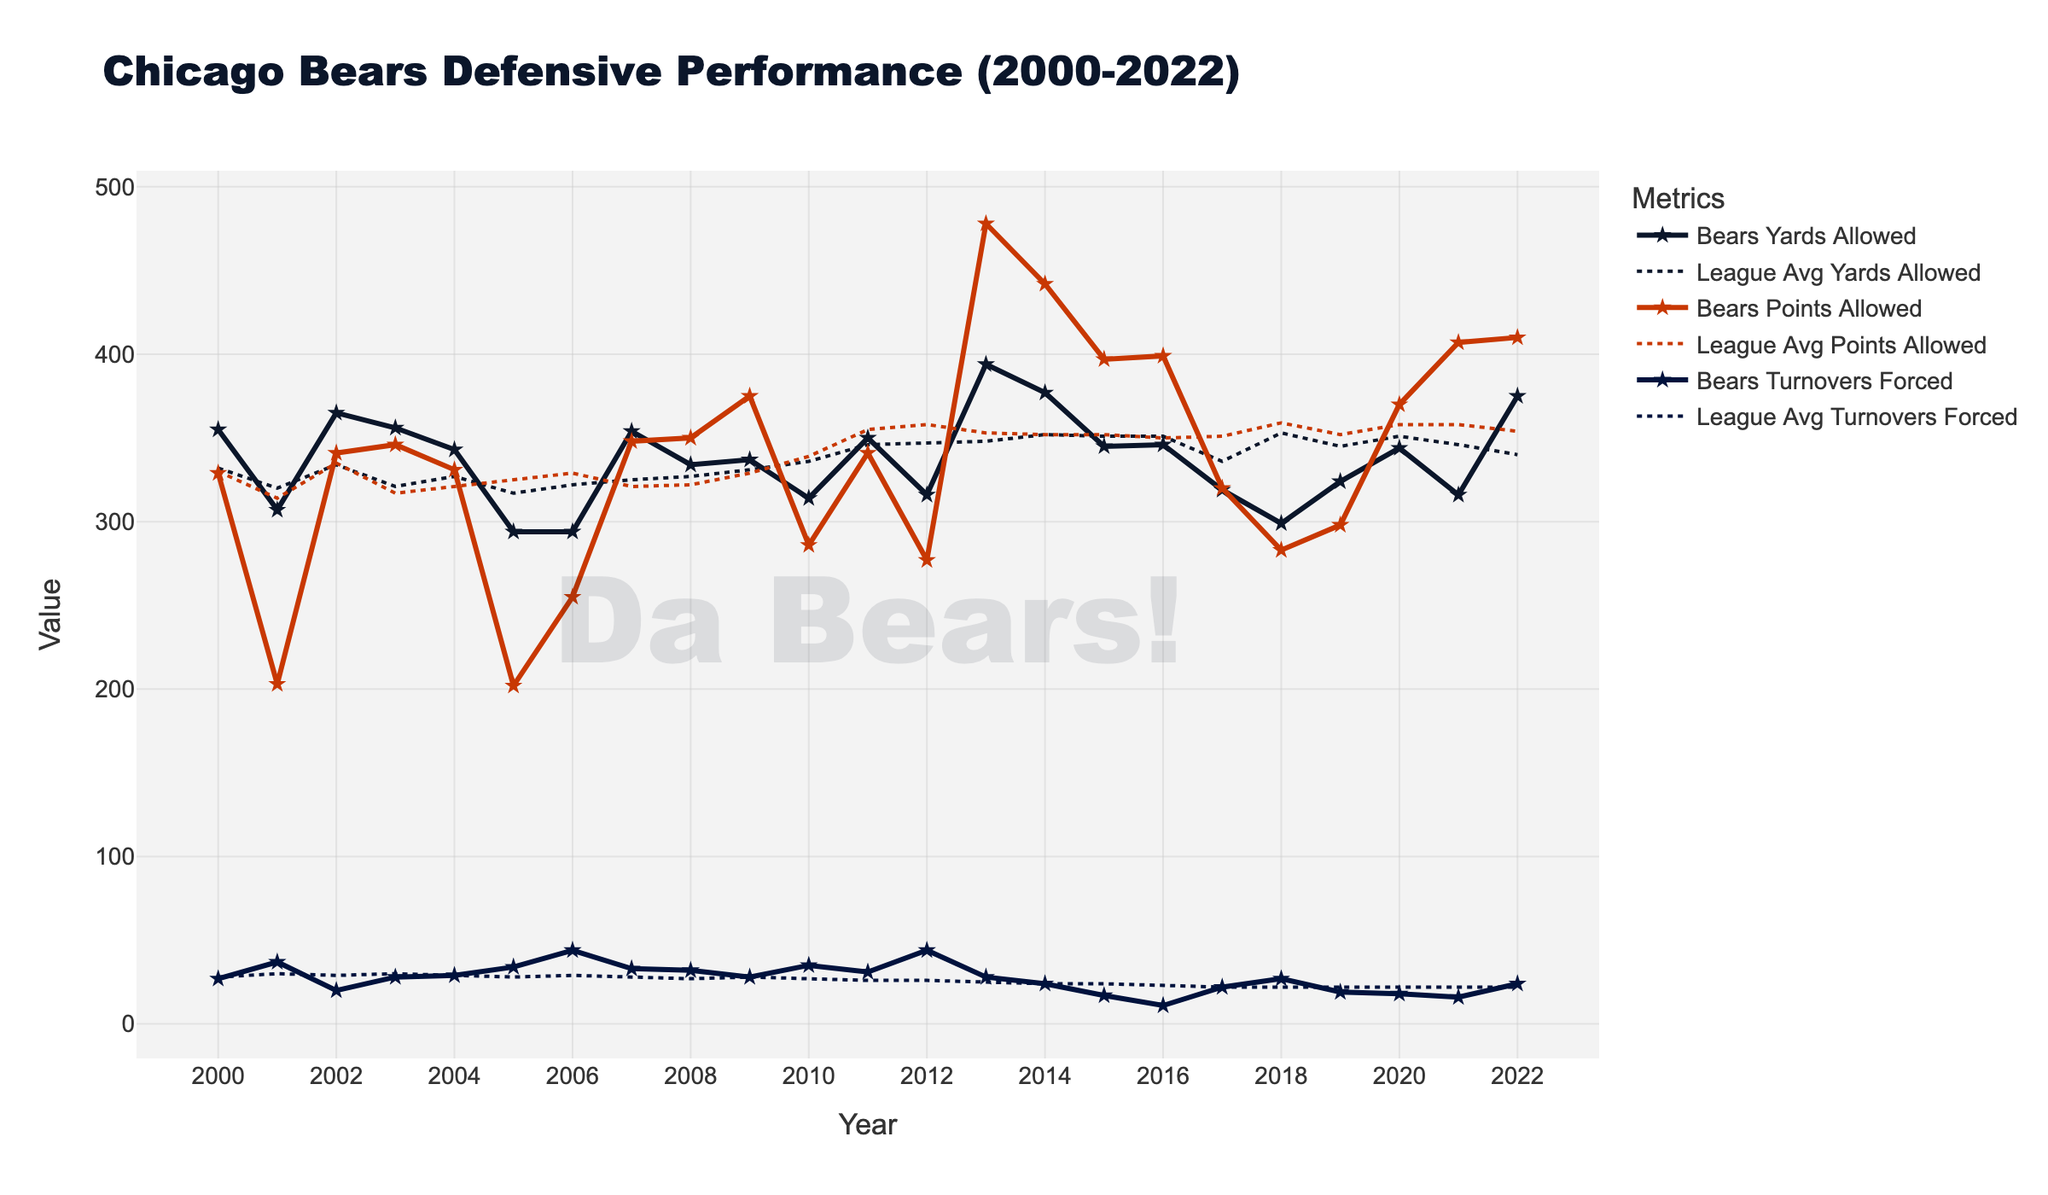How did the Bears' defensive yards allowed in 2005 compare to the league average? To determine this, locate the data points for 2005 in the "Yards Allowed" line for both the Bears and the league average. The Bears allowed approximately 294 yards, while the league average was around 317 yards.
Answer: The Bears allowed fewer yards than the league average in 2005 Which year did the Bears have the highest turnovers forced, and how did it compare to the league average that year? Examine the "Turnovers Forced" line for both the Bears and the league average. The year with the highest turnovers forced by the Bears is 2006 with approximately 44 turnovers, compared to the league average of around 29 turnovers.
Answer: 2006; The Bears forced more turnovers than the league average In which year did the Bears' points allowed significantly exceed the league average? Identify the year where there is the largest visual gap between the Bears' "Points Allowed" line and the league average line. The most pronounced gap occurs in 2013, where the Bears allowed 478 points compared to the league average of 353 points.
Answer: 2013 What's the average number of turnovers forced by the Bears from 2010-2015? Calculate the turnovers forced by the Bears each year from 2010 to 2015 (35, 31, 44, 28, 24, 17). Sum these values to get 179, then divide by 6 (the number of years) to get the average.
Answer: 29.83 Compare the Bears' defensive performance in terms of yards allowed in 2018 and 2019. Look at the "Yards Allowed" data points for 2018 and 2019. The Bears allowed approximately 299 yards in 2018 and 324 yards in 2019. Thus, the Bears allowed fewer yards in 2018 compared to 2019.
Answer: 2018 performance was better in terms of yards allowed During Jay Cutler's tenure (2009-2016), what was the trend in Bears' points allowed compared to the league average? Jay Cutler played for the Bears from 2009 to 2016. Observing the "Points Allowed" line for these years, the Bears' points allowed generally trend higher than the league average, peaking notably in 2013 and 2014.
Answer: Bears allowed more points than the league average during Cutler's tenure How did the Bears' points allowed in 2021 compare to the league average in that year? For the year 2021, find the "Points Allowed" line values. The Bears allowed approximately 407 points whereas the league average was around 358 points.
Answer: The Bears allowed more points than the league average in 2021 Which year did the Bears' yards allowed closely match the league average? Look for the points where the Bears' "Yards Allowed" line is closest to the league average line. In 2008 and 2009, the Bears' yards allowed (334 and 337) are very close to the league average (327 and 331 respectively).
Answer: 2008 or 2009 On average, how many more points than the league average did the Bears allow in 2013 and 2014? Calculate the difference between the Bears' points allowed (478 in 2013 and 442 in 2014) and the league average (353 in 2013 and 352 in 2014). Sum these differences (125 + 90 = 215), then divide by 2 (the number of years) to get the average.
Answer: 107.5 In what year did the Bears perform best in terms of points allowed compared to the league average? Identify the year where the gap between the Bears' "Points Allowed" and the league average is largest in favor of the Bears. In 2005, the Bears allowed 202 points, much lower than the league average of about 325 points.
Answer: 2005 